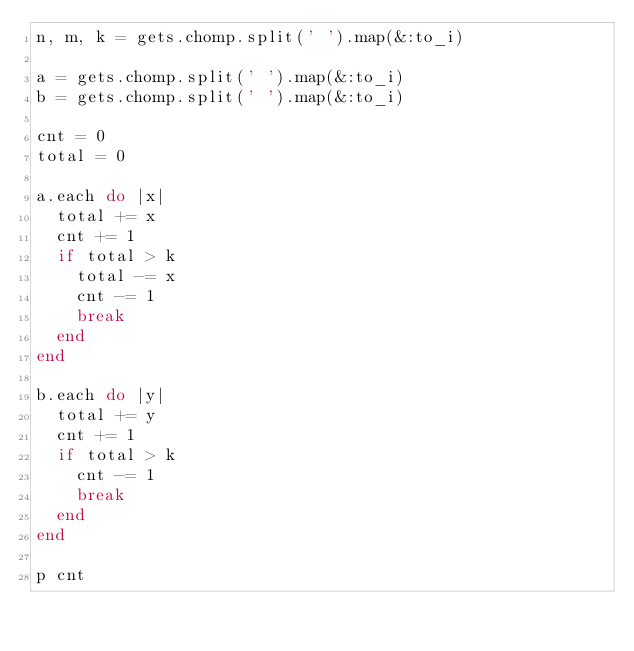<code> <loc_0><loc_0><loc_500><loc_500><_Ruby_>n, m, k = gets.chomp.split(' ').map(&:to_i)

a = gets.chomp.split(' ').map(&:to_i)
b = gets.chomp.split(' ').map(&:to_i)

cnt = 0
total = 0

a.each do |x|
  total += x
  cnt += 1
  if total > k
    total -= x
    cnt -= 1
    break
  end
end

b.each do |y|
  total += y
  cnt += 1
  if total > k
    cnt -= 1
    break
  end
end

p cnt</code> 